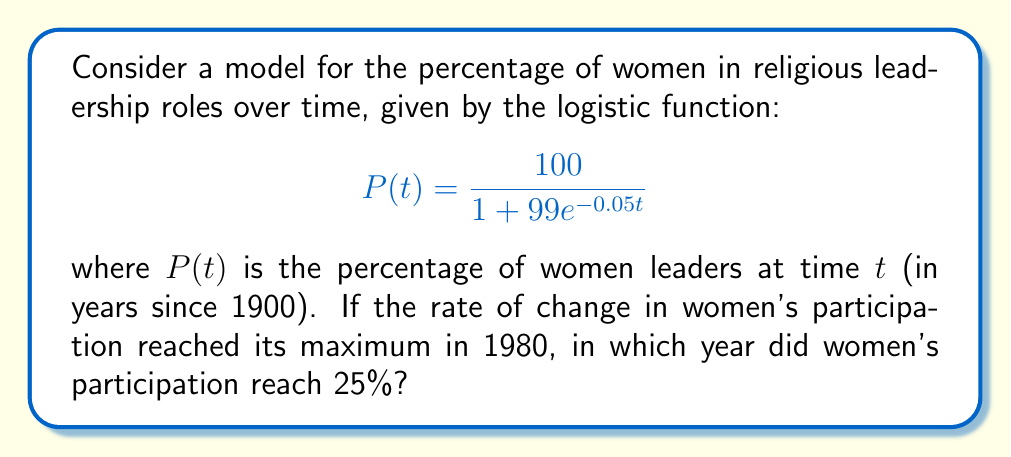Provide a solution to this math problem. 1. The logistic function has its maximum rate of change at its inflection point, which occurs at $t = \frac{\ln(99)}{0.05} \approx 92.1$ years after 1900, or 1992.

2. Given that the maximum rate occurred in 1980, we need to shift our time scale by 12 years. Let's define $s = t - 12$.

3. Our new function is:
   $$P(s) = \frac{100}{1 + 99e^{-0.05(s+12)}}$$

4. To find when women's participation reached 25%, we solve:
   $$25 = \frac{100}{1 + 99e^{-0.05(s+12)}}$$

5. Simplifying:
   $$4 = 1 + 99e^{-0.05(s+12)}$$
   $$3 = 99e^{-0.05(s+12)}$$
   $$\frac{1}{33} = e^{-0.05(s+12)}$$

6. Taking natural log of both sides:
   $$\ln(\frac{1}{33}) = -0.05(s+12)$$
   $$-3.4965 = -0.05(s+12)$$

7. Solving for $s$:
   $$s = \frac{3.4965}{0.05} - 12 \approx 57.93$$

8. Rounding to the nearest year and adding 1900, we get 1958.
Answer: 1958 